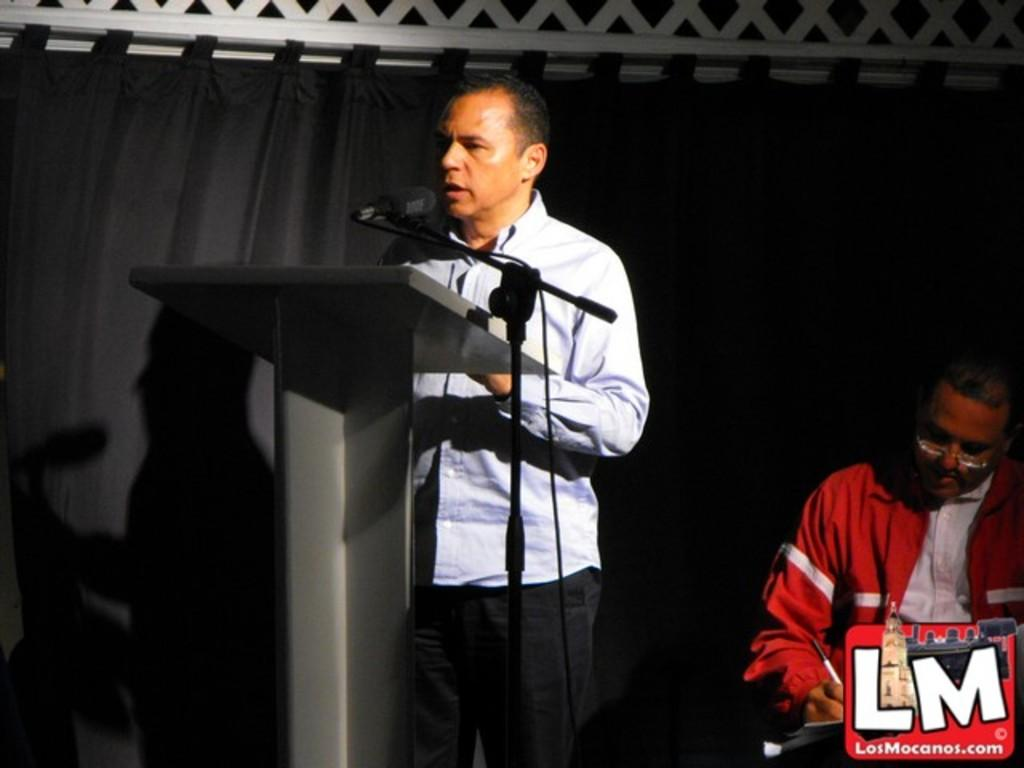What is the man near the podium doing in the image? The man is standing near a podium and speaking into a microphone. What is the man sitting on the right side doing? The sitting man is writing. What is the man standing near the podium wearing? The man is wearing a shirt and trousers. What is the sitting man wearing? The sitting man is wearing a red coat. What type of engine is visible in the image? There is no engine present in the image. Who is the owner of the red coat worn by the sitting man? The image does not provide information about the ownership of the red coat. 